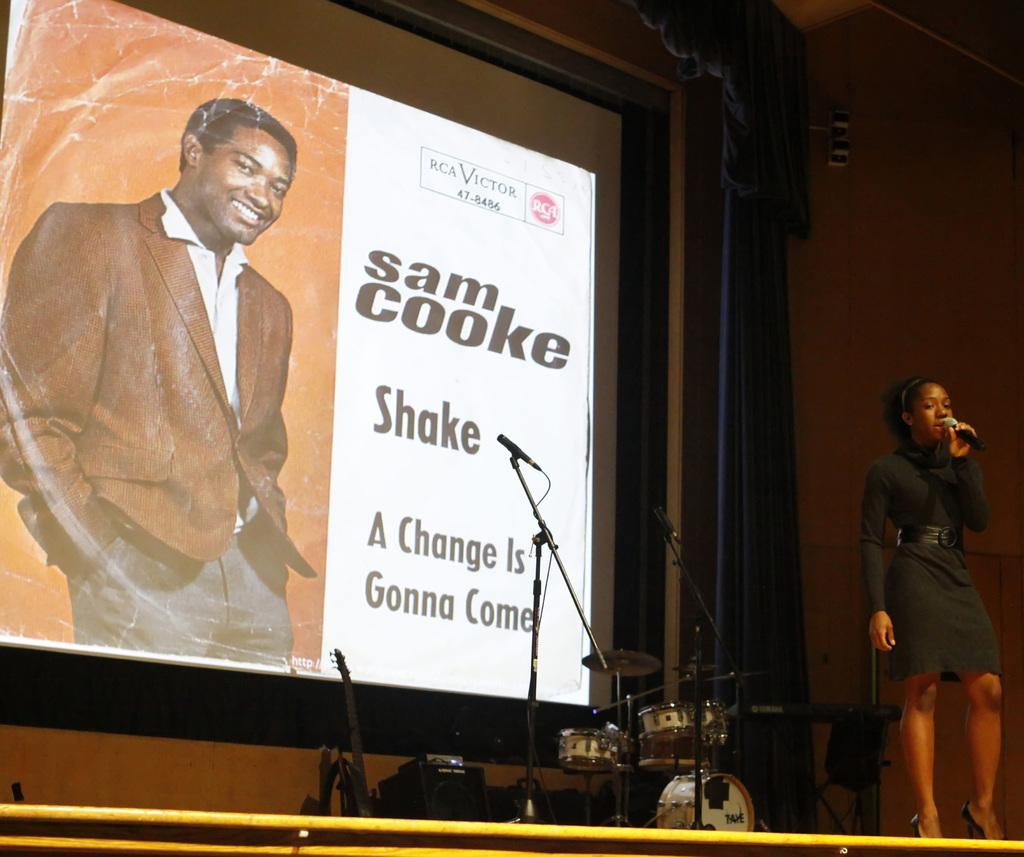Who is the main subject in the image? There is a woman in the image. What is the woman holding in her hand? The woman is holding a microphone in her hand. What can be seen in the background of the image? There is a screen in the background of the image. Who is visible on the screen? There is a man visible on the screen. What type of dinner is being served on the table in the image? There is no table or dinner present in the image. Can you see any ants crawling on the woman's arm in the image? There are no ants visible in the image. 